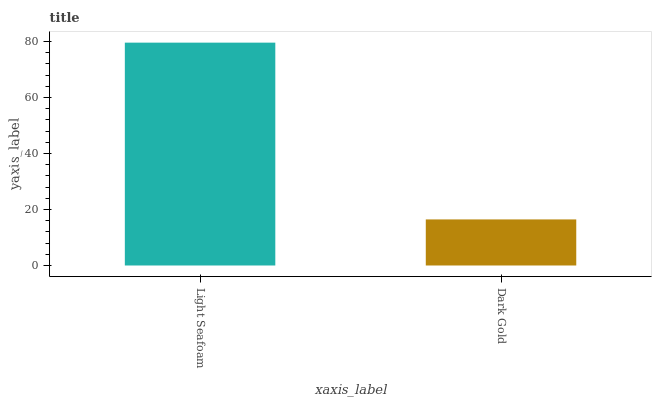Is Dark Gold the maximum?
Answer yes or no. No. Is Light Seafoam greater than Dark Gold?
Answer yes or no. Yes. Is Dark Gold less than Light Seafoam?
Answer yes or no. Yes. Is Dark Gold greater than Light Seafoam?
Answer yes or no. No. Is Light Seafoam less than Dark Gold?
Answer yes or no. No. Is Light Seafoam the high median?
Answer yes or no. Yes. Is Dark Gold the low median?
Answer yes or no. Yes. Is Dark Gold the high median?
Answer yes or no. No. Is Light Seafoam the low median?
Answer yes or no. No. 